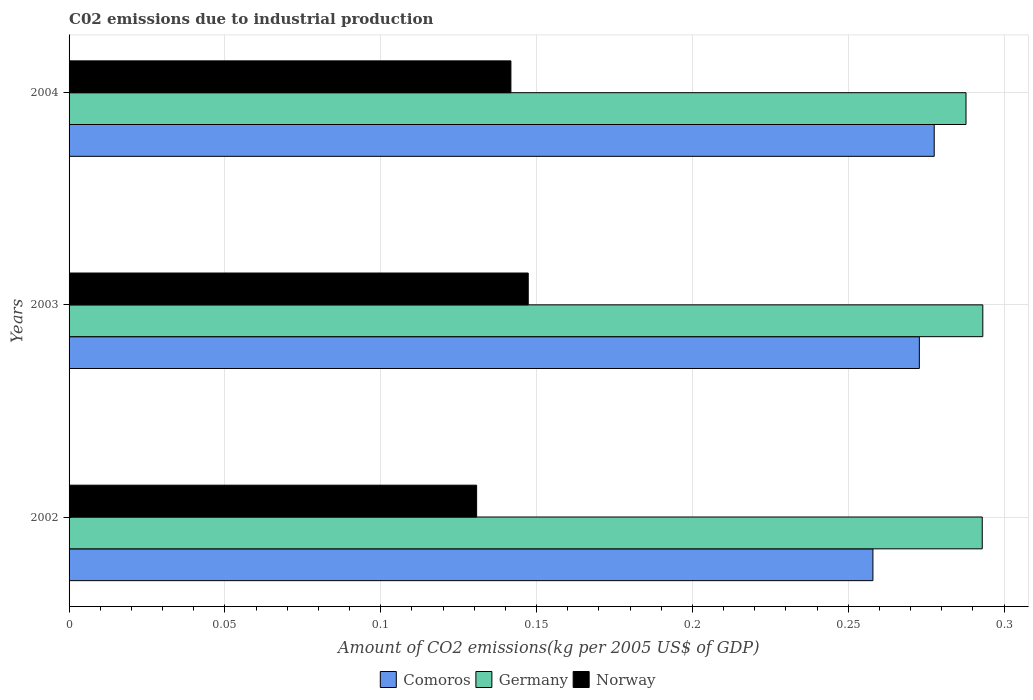What is the label of the 3rd group of bars from the top?
Offer a terse response. 2002. What is the amount of CO2 emitted due to industrial production in Comoros in 2004?
Your response must be concise. 0.28. Across all years, what is the maximum amount of CO2 emitted due to industrial production in Comoros?
Ensure brevity in your answer.  0.28. Across all years, what is the minimum amount of CO2 emitted due to industrial production in Germany?
Provide a succinct answer. 0.29. In which year was the amount of CO2 emitted due to industrial production in Germany maximum?
Your response must be concise. 2003. What is the total amount of CO2 emitted due to industrial production in Norway in the graph?
Your response must be concise. 0.42. What is the difference between the amount of CO2 emitted due to industrial production in Comoros in 2002 and that in 2003?
Your response must be concise. -0.01. What is the difference between the amount of CO2 emitted due to industrial production in Norway in 2004 and the amount of CO2 emitted due to industrial production in Germany in 2002?
Your answer should be compact. -0.15. What is the average amount of CO2 emitted due to industrial production in Germany per year?
Offer a terse response. 0.29. In the year 2002, what is the difference between the amount of CO2 emitted due to industrial production in Comoros and amount of CO2 emitted due to industrial production in Germany?
Make the answer very short. -0.04. In how many years, is the amount of CO2 emitted due to industrial production in Comoros greater than 0.2 kg?
Offer a very short reply. 3. What is the ratio of the amount of CO2 emitted due to industrial production in Comoros in 2003 to that in 2004?
Give a very brief answer. 0.98. What is the difference between the highest and the second highest amount of CO2 emitted due to industrial production in Norway?
Your response must be concise. 0.01. What is the difference between the highest and the lowest amount of CO2 emitted due to industrial production in Norway?
Your answer should be compact. 0.02. In how many years, is the amount of CO2 emitted due to industrial production in Germany greater than the average amount of CO2 emitted due to industrial production in Germany taken over all years?
Offer a very short reply. 2. Is the sum of the amount of CO2 emitted due to industrial production in Germany in 2003 and 2004 greater than the maximum amount of CO2 emitted due to industrial production in Comoros across all years?
Offer a terse response. Yes. What does the 3rd bar from the top in 2003 represents?
Keep it short and to the point. Comoros. What does the 1st bar from the bottom in 2004 represents?
Your answer should be very brief. Comoros. Is it the case that in every year, the sum of the amount of CO2 emitted due to industrial production in Norway and amount of CO2 emitted due to industrial production in Comoros is greater than the amount of CO2 emitted due to industrial production in Germany?
Ensure brevity in your answer.  Yes. Are all the bars in the graph horizontal?
Your answer should be compact. Yes. Does the graph contain grids?
Offer a very short reply. Yes. How are the legend labels stacked?
Offer a terse response. Horizontal. What is the title of the graph?
Keep it short and to the point. C02 emissions due to industrial production. Does "Brazil" appear as one of the legend labels in the graph?
Offer a terse response. No. What is the label or title of the X-axis?
Your answer should be compact. Amount of CO2 emissions(kg per 2005 US$ of GDP). What is the label or title of the Y-axis?
Your answer should be very brief. Years. What is the Amount of CO2 emissions(kg per 2005 US$ of GDP) of Comoros in 2002?
Offer a terse response. 0.26. What is the Amount of CO2 emissions(kg per 2005 US$ of GDP) of Germany in 2002?
Provide a succinct answer. 0.29. What is the Amount of CO2 emissions(kg per 2005 US$ of GDP) in Norway in 2002?
Keep it short and to the point. 0.13. What is the Amount of CO2 emissions(kg per 2005 US$ of GDP) of Comoros in 2003?
Keep it short and to the point. 0.27. What is the Amount of CO2 emissions(kg per 2005 US$ of GDP) of Germany in 2003?
Your answer should be compact. 0.29. What is the Amount of CO2 emissions(kg per 2005 US$ of GDP) in Norway in 2003?
Your response must be concise. 0.15. What is the Amount of CO2 emissions(kg per 2005 US$ of GDP) in Comoros in 2004?
Provide a short and direct response. 0.28. What is the Amount of CO2 emissions(kg per 2005 US$ of GDP) of Germany in 2004?
Keep it short and to the point. 0.29. What is the Amount of CO2 emissions(kg per 2005 US$ of GDP) in Norway in 2004?
Your response must be concise. 0.14. Across all years, what is the maximum Amount of CO2 emissions(kg per 2005 US$ of GDP) of Comoros?
Provide a short and direct response. 0.28. Across all years, what is the maximum Amount of CO2 emissions(kg per 2005 US$ of GDP) in Germany?
Give a very brief answer. 0.29. Across all years, what is the maximum Amount of CO2 emissions(kg per 2005 US$ of GDP) in Norway?
Provide a succinct answer. 0.15. Across all years, what is the minimum Amount of CO2 emissions(kg per 2005 US$ of GDP) of Comoros?
Provide a short and direct response. 0.26. Across all years, what is the minimum Amount of CO2 emissions(kg per 2005 US$ of GDP) of Germany?
Your answer should be compact. 0.29. Across all years, what is the minimum Amount of CO2 emissions(kg per 2005 US$ of GDP) of Norway?
Keep it short and to the point. 0.13. What is the total Amount of CO2 emissions(kg per 2005 US$ of GDP) in Comoros in the graph?
Your answer should be very brief. 0.81. What is the total Amount of CO2 emissions(kg per 2005 US$ of GDP) in Germany in the graph?
Offer a terse response. 0.87. What is the total Amount of CO2 emissions(kg per 2005 US$ of GDP) in Norway in the graph?
Offer a very short reply. 0.42. What is the difference between the Amount of CO2 emissions(kg per 2005 US$ of GDP) of Comoros in 2002 and that in 2003?
Offer a very short reply. -0.01. What is the difference between the Amount of CO2 emissions(kg per 2005 US$ of GDP) of Germany in 2002 and that in 2003?
Provide a succinct answer. -0. What is the difference between the Amount of CO2 emissions(kg per 2005 US$ of GDP) of Norway in 2002 and that in 2003?
Ensure brevity in your answer.  -0.02. What is the difference between the Amount of CO2 emissions(kg per 2005 US$ of GDP) in Comoros in 2002 and that in 2004?
Your answer should be very brief. -0.02. What is the difference between the Amount of CO2 emissions(kg per 2005 US$ of GDP) in Germany in 2002 and that in 2004?
Offer a terse response. 0.01. What is the difference between the Amount of CO2 emissions(kg per 2005 US$ of GDP) in Norway in 2002 and that in 2004?
Give a very brief answer. -0.01. What is the difference between the Amount of CO2 emissions(kg per 2005 US$ of GDP) of Comoros in 2003 and that in 2004?
Your response must be concise. -0. What is the difference between the Amount of CO2 emissions(kg per 2005 US$ of GDP) of Germany in 2003 and that in 2004?
Provide a succinct answer. 0.01. What is the difference between the Amount of CO2 emissions(kg per 2005 US$ of GDP) of Norway in 2003 and that in 2004?
Offer a terse response. 0.01. What is the difference between the Amount of CO2 emissions(kg per 2005 US$ of GDP) of Comoros in 2002 and the Amount of CO2 emissions(kg per 2005 US$ of GDP) of Germany in 2003?
Make the answer very short. -0.04. What is the difference between the Amount of CO2 emissions(kg per 2005 US$ of GDP) in Comoros in 2002 and the Amount of CO2 emissions(kg per 2005 US$ of GDP) in Norway in 2003?
Provide a short and direct response. 0.11. What is the difference between the Amount of CO2 emissions(kg per 2005 US$ of GDP) of Germany in 2002 and the Amount of CO2 emissions(kg per 2005 US$ of GDP) of Norway in 2003?
Ensure brevity in your answer.  0.15. What is the difference between the Amount of CO2 emissions(kg per 2005 US$ of GDP) of Comoros in 2002 and the Amount of CO2 emissions(kg per 2005 US$ of GDP) of Germany in 2004?
Provide a short and direct response. -0.03. What is the difference between the Amount of CO2 emissions(kg per 2005 US$ of GDP) of Comoros in 2002 and the Amount of CO2 emissions(kg per 2005 US$ of GDP) of Norway in 2004?
Your answer should be very brief. 0.12. What is the difference between the Amount of CO2 emissions(kg per 2005 US$ of GDP) in Germany in 2002 and the Amount of CO2 emissions(kg per 2005 US$ of GDP) in Norway in 2004?
Provide a short and direct response. 0.15. What is the difference between the Amount of CO2 emissions(kg per 2005 US$ of GDP) in Comoros in 2003 and the Amount of CO2 emissions(kg per 2005 US$ of GDP) in Germany in 2004?
Your answer should be very brief. -0.01. What is the difference between the Amount of CO2 emissions(kg per 2005 US$ of GDP) of Comoros in 2003 and the Amount of CO2 emissions(kg per 2005 US$ of GDP) of Norway in 2004?
Your answer should be very brief. 0.13. What is the difference between the Amount of CO2 emissions(kg per 2005 US$ of GDP) of Germany in 2003 and the Amount of CO2 emissions(kg per 2005 US$ of GDP) of Norway in 2004?
Give a very brief answer. 0.15. What is the average Amount of CO2 emissions(kg per 2005 US$ of GDP) in Comoros per year?
Offer a terse response. 0.27. What is the average Amount of CO2 emissions(kg per 2005 US$ of GDP) in Germany per year?
Offer a terse response. 0.29. What is the average Amount of CO2 emissions(kg per 2005 US$ of GDP) in Norway per year?
Provide a succinct answer. 0.14. In the year 2002, what is the difference between the Amount of CO2 emissions(kg per 2005 US$ of GDP) in Comoros and Amount of CO2 emissions(kg per 2005 US$ of GDP) in Germany?
Make the answer very short. -0.04. In the year 2002, what is the difference between the Amount of CO2 emissions(kg per 2005 US$ of GDP) in Comoros and Amount of CO2 emissions(kg per 2005 US$ of GDP) in Norway?
Your answer should be compact. 0.13. In the year 2002, what is the difference between the Amount of CO2 emissions(kg per 2005 US$ of GDP) in Germany and Amount of CO2 emissions(kg per 2005 US$ of GDP) in Norway?
Make the answer very short. 0.16. In the year 2003, what is the difference between the Amount of CO2 emissions(kg per 2005 US$ of GDP) of Comoros and Amount of CO2 emissions(kg per 2005 US$ of GDP) of Germany?
Your answer should be very brief. -0.02. In the year 2003, what is the difference between the Amount of CO2 emissions(kg per 2005 US$ of GDP) of Comoros and Amount of CO2 emissions(kg per 2005 US$ of GDP) of Norway?
Your answer should be compact. 0.13. In the year 2003, what is the difference between the Amount of CO2 emissions(kg per 2005 US$ of GDP) in Germany and Amount of CO2 emissions(kg per 2005 US$ of GDP) in Norway?
Keep it short and to the point. 0.15. In the year 2004, what is the difference between the Amount of CO2 emissions(kg per 2005 US$ of GDP) of Comoros and Amount of CO2 emissions(kg per 2005 US$ of GDP) of Germany?
Your answer should be very brief. -0.01. In the year 2004, what is the difference between the Amount of CO2 emissions(kg per 2005 US$ of GDP) in Comoros and Amount of CO2 emissions(kg per 2005 US$ of GDP) in Norway?
Give a very brief answer. 0.14. In the year 2004, what is the difference between the Amount of CO2 emissions(kg per 2005 US$ of GDP) of Germany and Amount of CO2 emissions(kg per 2005 US$ of GDP) of Norway?
Offer a very short reply. 0.15. What is the ratio of the Amount of CO2 emissions(kg per 2005 US$ of GDP) in Comoros in 2002 to that in 2003?
Give a very brief answer. 0.95. What is the ratio of the Amount of CO2 emissions(kg per 2005 US$ of GDP) in Germany in 2002 to that in 2003?
Your answer should be compact. 1. What is the ratio of the Amount of CO2 emissions(kg per 2005 US$ of GDP) of Norway in 2002 to that in 2003?
Your answer should be compact. 0.89. What is the ratio of the Amount of CO2 emissions(kg per 2005 US$ of GDP) of Comoros in 2002 to that in 2004?
Provide a succinct answer. 0.93. What is the ratio of the Amount of CO2 emissions(kg per 2005 US$ of GDP) in Germany in 2002 to that in 2004?
Ensure brevity in your answer.  1.02. What is the ratio of the Amount of CO2 emissions(kg per 2005 US$ of GDP) of Norway in 2002 to that in 2004?
Make the answer very short. 0.92. What is the ratio of the Amount of CO2 emissions(kg per 2005 US$ of GDP) in Comoros in 2003 to that in 2004?
Provide a succinct answer. 0.98. What is the ratio of the Amount of CO2 emissions(kg per 2005 US$ of GDP) in Germany in 2003 to that in 2004?
Provide a succinct answer. 1.02. What is the ratio of the Amount of CO2 emissions(kg per 2005 US$ of GDP) in Norway in 2003 to that in 2004?
Your answer should be compact. 1.04. What is the difference between the highest and the second highest Amount of CO2 emissions(kg per 2005 US$ of GDP) of Comoros?
Provide a succinct answer. 0. What is the difference between the highest and the second highest Amount of CO2 emissions(kg per 2005 US$ of GDP) of Norway?
Give a very brief answer. 0.01. What is the difference between the highest and the lowest Amount of CO2 emissions(kg per 2005 US$ of GDP) of Comoros?
Your response must be concise. 0.02. What is the difference between the highest and the lowest Amount of CO2 emissions(kg per 2005 US$ of GDP) of Germany?
Your answer should be very brief. 0.01. What is the difference between the highest and the lowest Amount of CO2 emissions(kg per 2005 US$ of GDP) in Norway?
Keep it short and to the point. 0.02. 